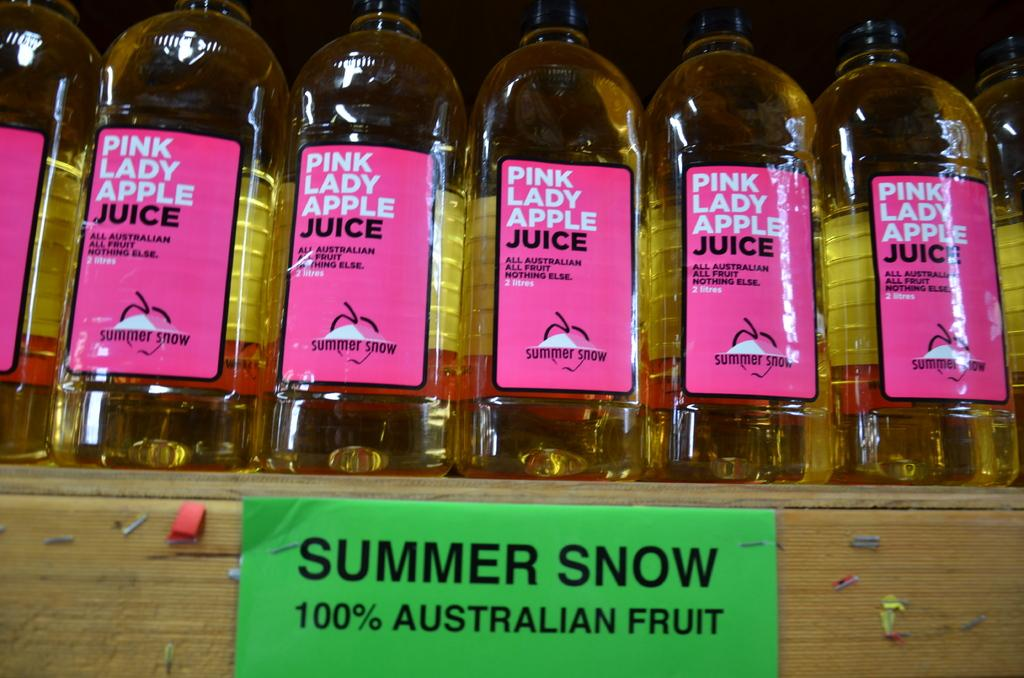<image>
Share a concise interpretation of the image provided. Seven bottles of Pink Lady Apple juice are lined up neatly on a shelf. 